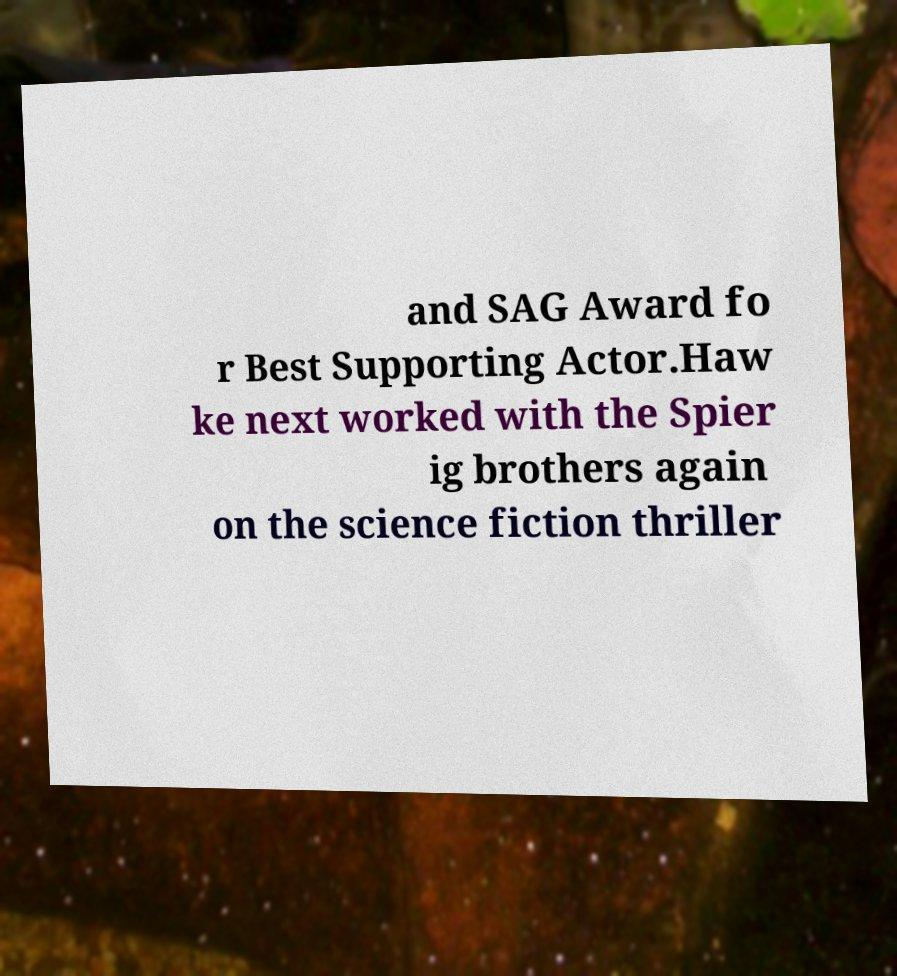Please read and relay the text visible in this image. What does it say? and SAG Award fo r Best Supporting Actor.Haw ke next worked with the Spier ig brothers again on the science fiction thriller 